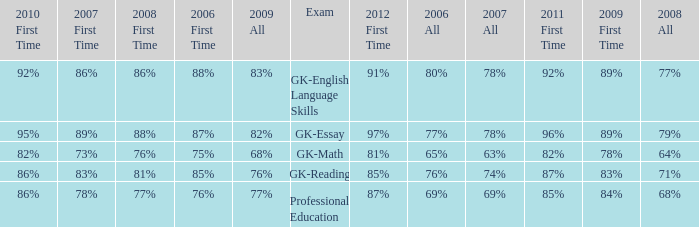What is the percentage for all 2008 when all in 2007 is 69%? 68%. 